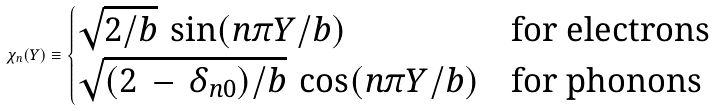Convert formula to latex. <formula><loc_0><loc_0><loc_500><loc_500>\chi _ { n } ( Y ) \equiv \begin{cases} \sqrt { 2 / b } \, \sin ( n \pi Y / b ) & \text {for electrons} \\ \sqrt { ( 2 \, - \, \delta _ { n 0 } ) / b } \, \cos ( n \pi Y / b ) & \text {for phonons} \end{cases}</formula> 